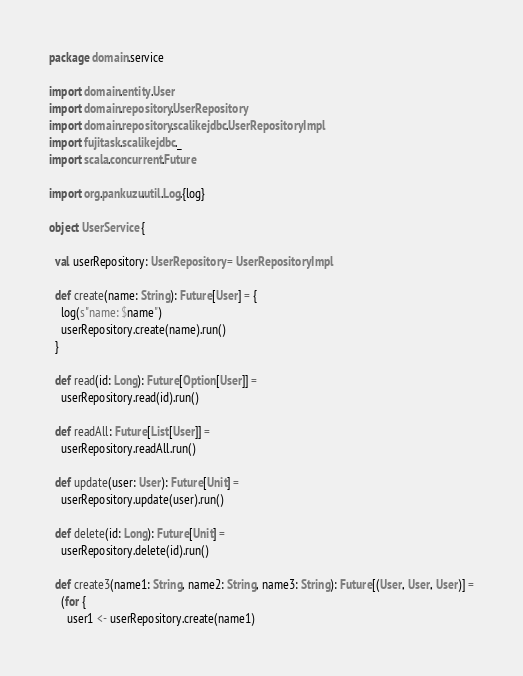Convert code to text. <code><loc_0><loc_0><loc_500><loc_500><_Scala_>package domain.service

import domain.entity.User
import domain.repository.UserRepository
import domain.repository.scalikejdbc.UserRepositoryImpl
import fujitask.scalikejdbc._
import scala.concurrent.Future

import org.pankuzu.util.Log.{log}

object UserService {

  val userRepository: UserRepository = UserRepositoryImpl

  def create(name: String): Future[User] = {
    log(s"name: $name")
    userRepository.create(name).run()
  }

  def read(id: Long): Future[Option[User]] =
    userRepository.read(id).run()

  def readAll: Future[List[User]] =
    userRepository.readAll.run()

  def update(user: User): Future[Unit] =
    userRepository.update(user).run()

  def delete(id: Long): Future[Unit] =
    userRepository.delete(id).run()

  def create3(name1: String, name2: String, name3: String): Future[(User, User, User)] =
    (for {
      user1 <- userRepository.create(name1)</code> 